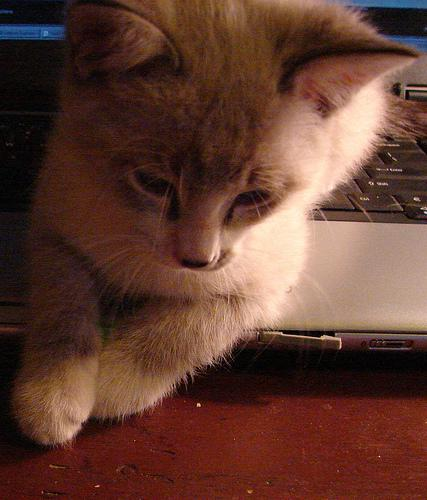Question: what animal is shown in the picture?
Choices:
A. Cats.
B. Furry ones.
C. Kitten.
D. Feline.
Answer with the letter. Answer: C Question: where is the kitten looking?
Choices:
A. To the ground.
B. Downward.
C. At something.
D. Up.
Answer with the letter. Answer: B Question: how many ears are in the picture?
Choices:
A. Three.
B. Six.
C. Two.
D. Eight.
Answer with the letter. Answer: C 